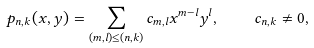<formula> <loc_0><loc_0><loc_500><loc_500>p _ { n , k } ( x , y ) = \sum _ { ( m , l ) \leq ( n , k ) } c _ { m , l } x ^ { m - l } y ^ { l } , \quad c _ { n , k } \ne 0 ,</formula> 